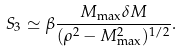<formula> <loc_0><loc_0><loc_500><loc_500>S _ { 3 } \simeq \beta \frac { M _ { \max } \delta M } { ( \rho ^ { 2 } - M _ { \max } ^ { 2 } ) ^ { 1 / 2 } } .</formula> 